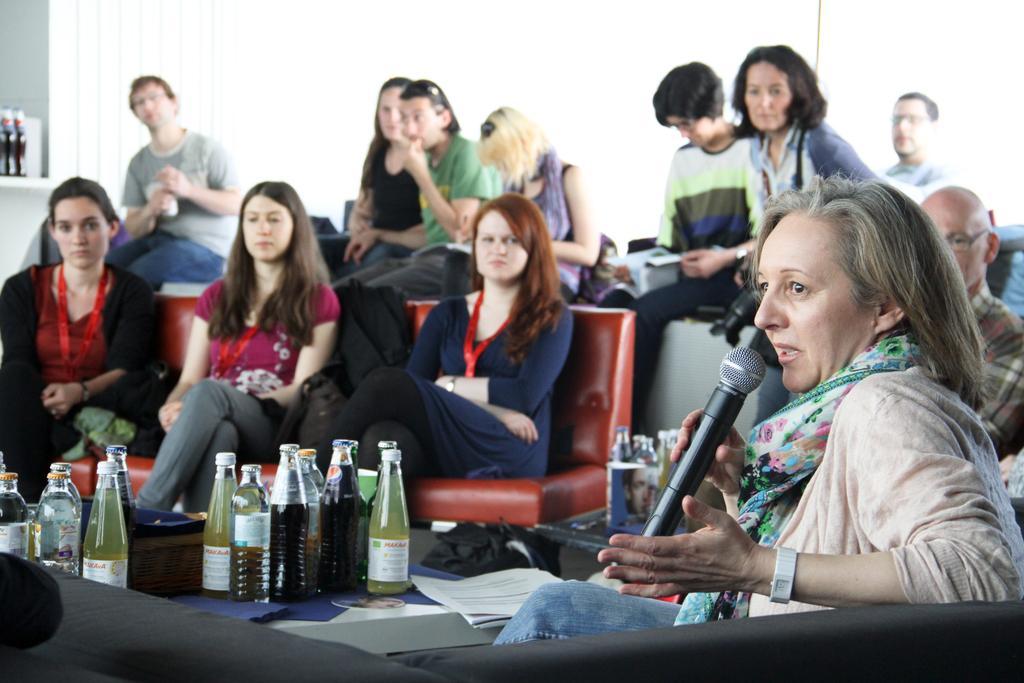Describe this image in one or two sentences. In the picture we can see some women are sitting on the chairs near the table, on the table we can see a bottles of drinks, and some papers, cloth on it, in the background some boys are sitting on a table and some girls also, and we can also see a white curtain with wall. 